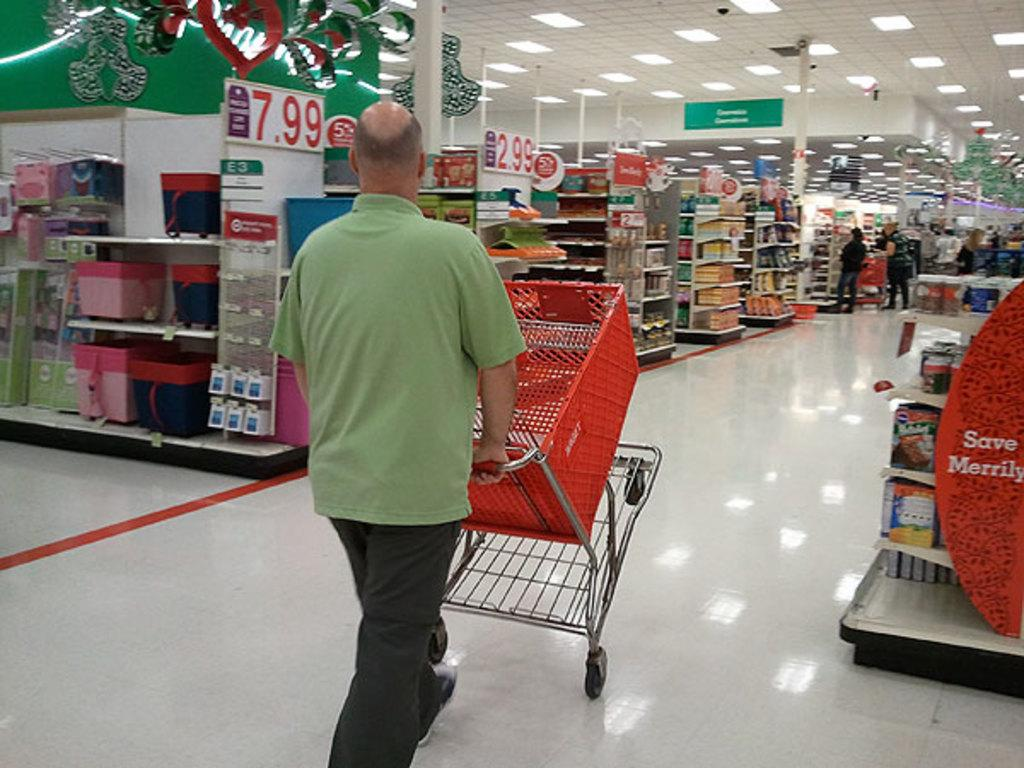<image>
Render a clear and concise summary of the photo. A man browses the aisles of Target, where a product is on display and priced at $7.99. 